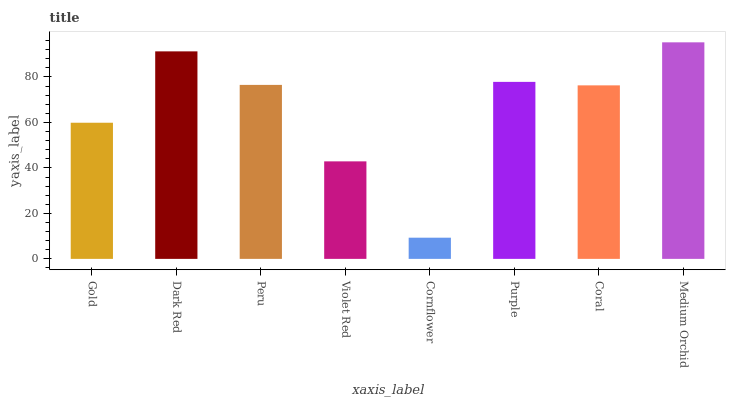Is Dark Red the minimum?
Answer yes or no. No. Is Dark Red the maximum?
Answer yes or no. No. Is Dark Red greater than Gold?
Answer yes or no. Yes. Is Gold less than Dark Red?
Answer yes or no. Yes. Is Gold greater than Dark Red?
Answer yes or no. No. Is Dark Red less than Gold?
Answer yes or no. No. Is Peru the high median?
Answer yes or no. Yes. Is Coral the low median?
Answer yes or no. Yes. Is Dark Red the high median?
Answer yes or no. No. Is Gold the low median?
Answer yes or no. No. 